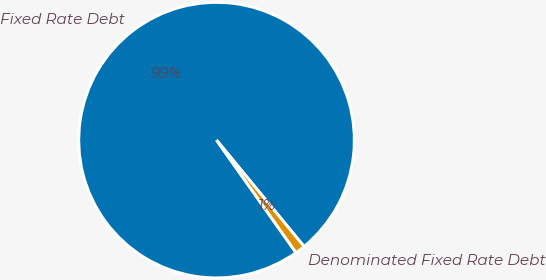Convert chart to OTSL. <chart><loc_0><loc_0><loc_500><loc_500><pie_chart><fcel>Fixed Rate Debt<fcel>Denominated Fixed Rate Debt<nl><fcel>98.83%<fcel>1.17%<nl></chart> 